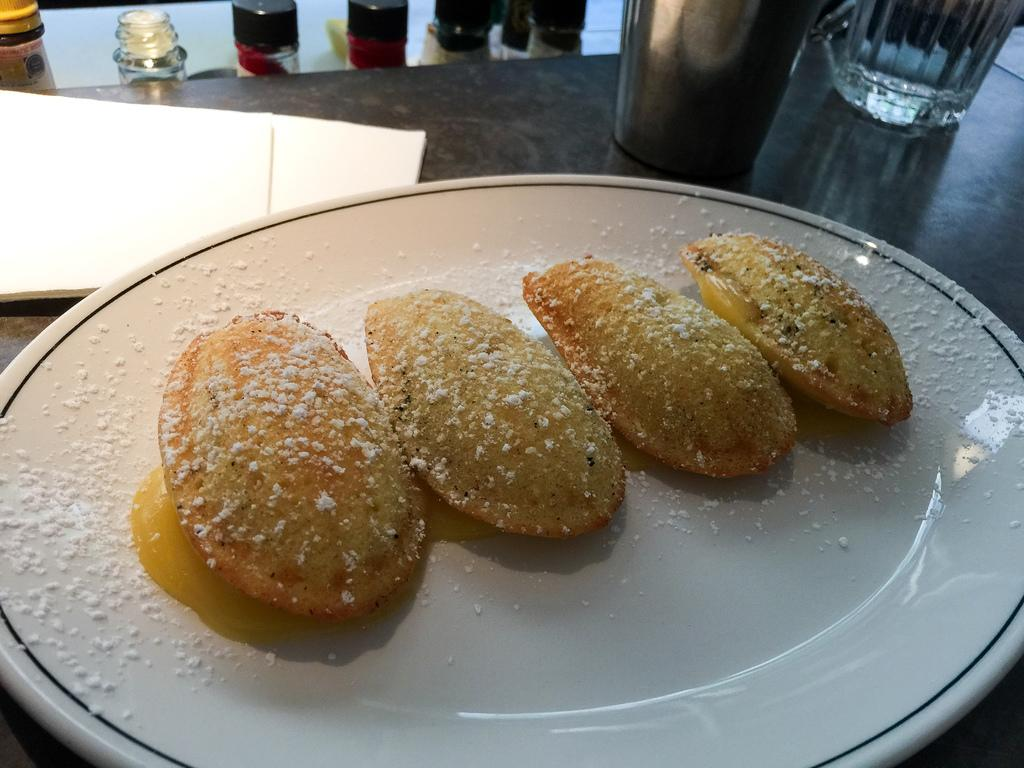What is on the plate in the image? There are food items on the plate in the image. What can be seen on the table in the image? There are glasses and tissues on the table in the image. What is located beside the table in the image? There are bottles beside the table in the image. What type of yarn is the yarn used by the tiger in the image? There is no yarn or tiger present in the image. What color is the ink used to write on the table in the image? There is no ink or writing on the table in the image. 